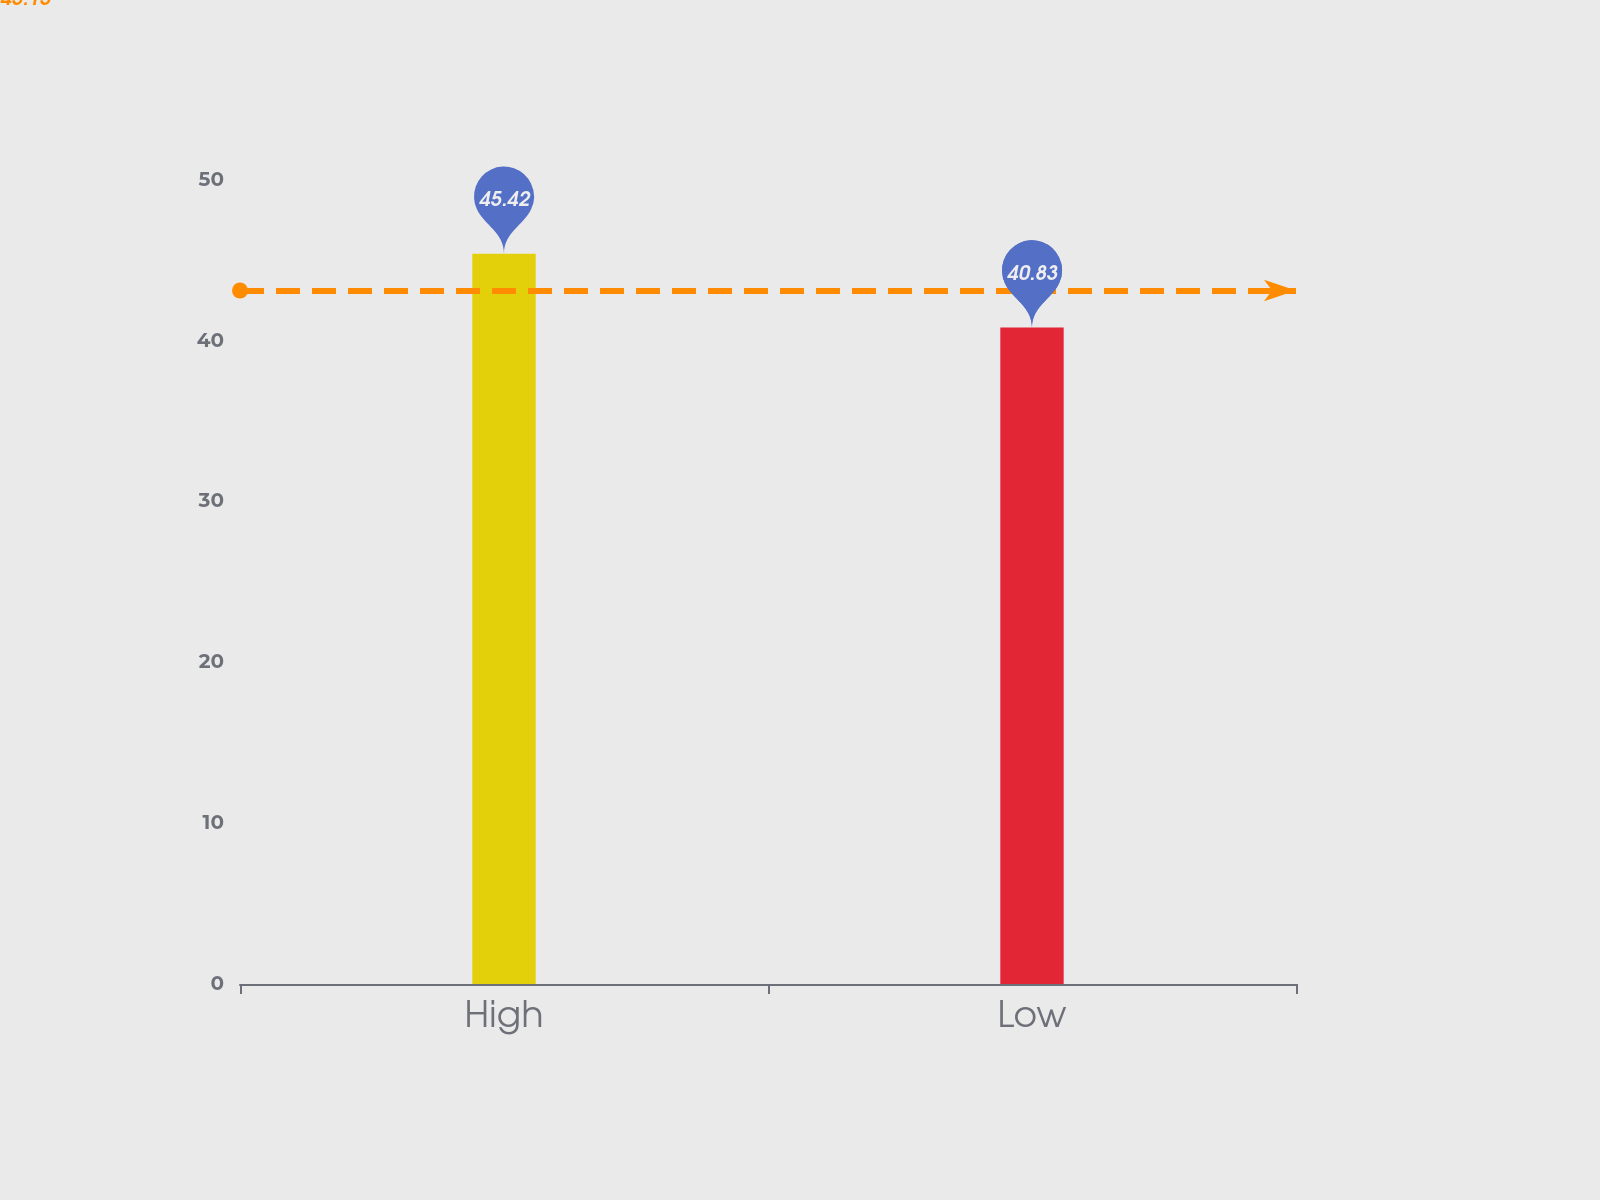Convert chart to OTSL. <chart><loc_0><loc_0><loc_500><loc_500><bar_chart><fcel>High<fcel>Low<nl><fcel>45.42<fcel>40.83<nl></chart> 